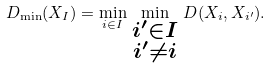Convert formula to latex. <formula><loc_0><loc_0><loc_500><loc_500>D _ { \min } ( X _ { I } ) = \min _ { i \in I } \, \min _ { \substack { i ^ { \prime } \in I \\ i ^ { \prime } \not = i } } \, D ( X _ { i } , X _ { i ^ { \prime } } ) .</formula> 